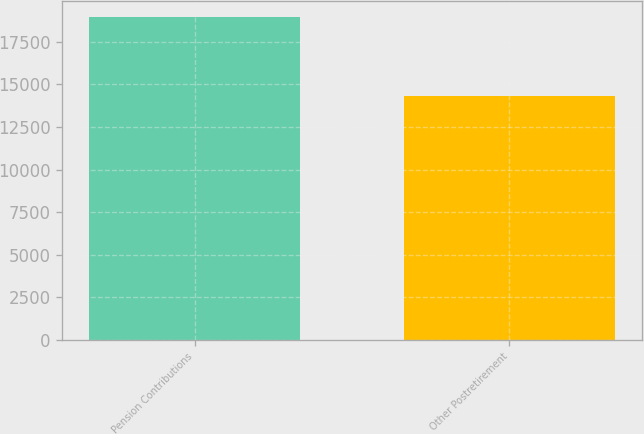<chart> <loc_0><loc_0><loc_500><loc_500><bar_chart><fcel>Pension Contributions<fcel>Other Postretirement<nl><fcel>18948<fcel>14317<nl></chart> 